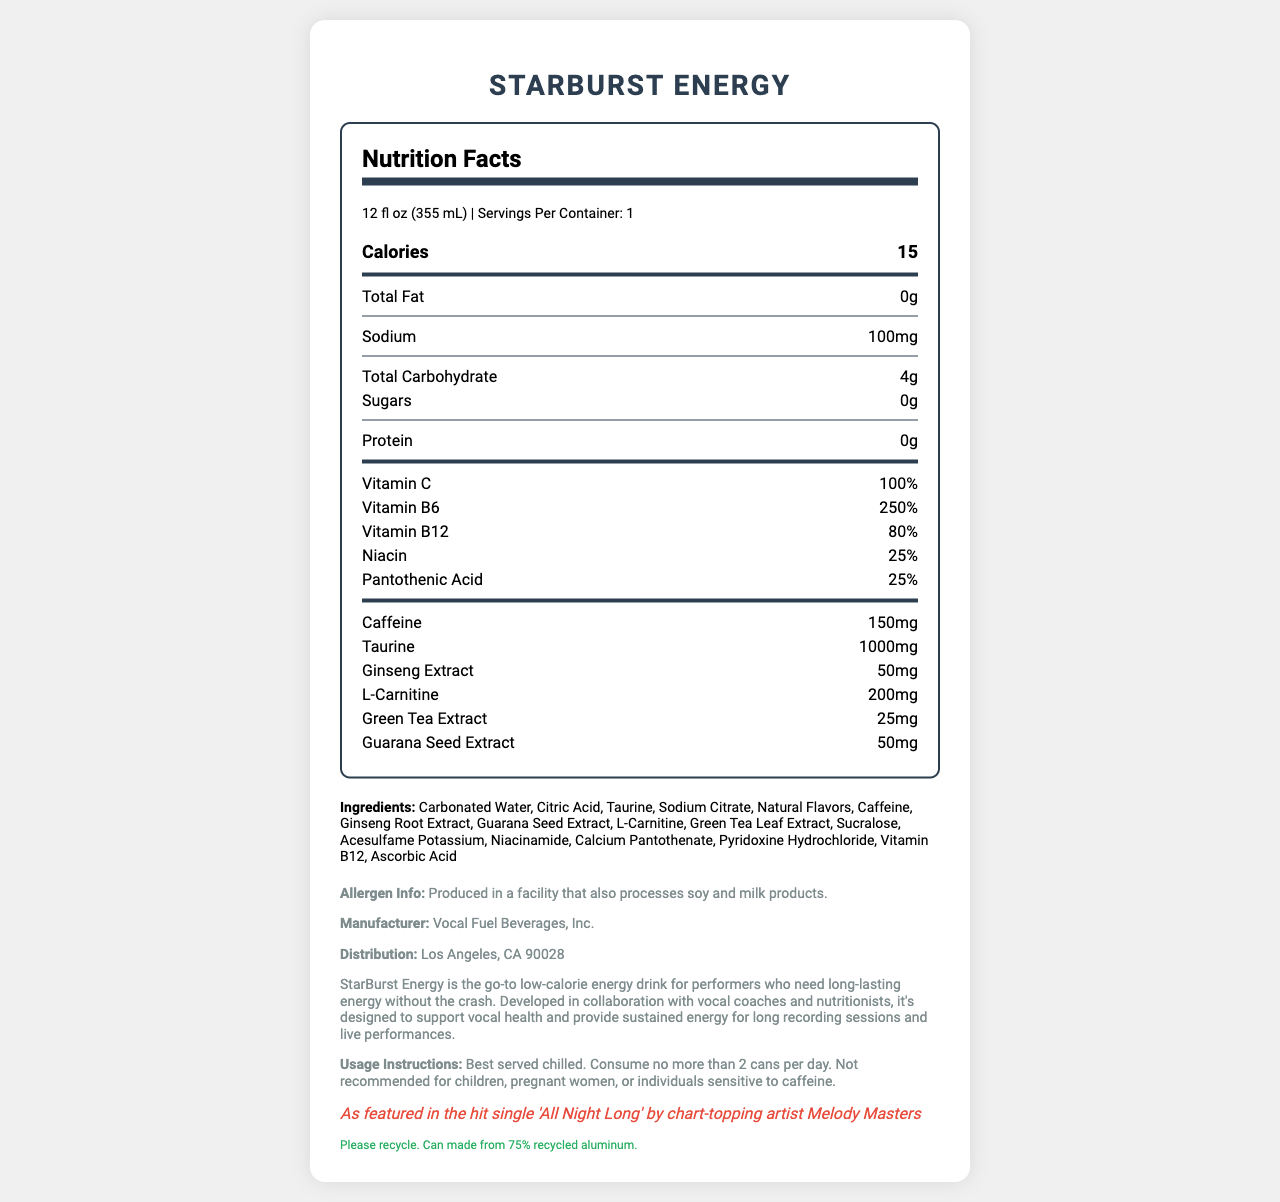what is the serving size of StarBurst Energy? The serving size is clearly stated at the beginning of the document under the heading "Nutrition Facts".
Answer: 12 fl oz (355 mL) how many calories are in one serving of StarBurst Energy? The calories count is prominently displayed under the "Nutrition Facts" heading.
Answer: 15 how much caffeine is in one serving of StarBurst Energy? The amount of caffeine is listed under the nutrition details in the document.
Answer: 150 mg what is the percentage of Vitamin B6 in one serving of StarBurst Energy? The percentage of Vitamin B6 is mentioned in the nutrition facts section under vitamins.
Answer: 250% name three ingredients in StarBurst Energy. The ingredients list includes these as part of the overall composition of the drink.
Answer: Carbonated Water, Citric Acid, Taurine which nutritional component is not included in StarBurst Energy? A. Protein B. Sodium C. Sugars D. Total Fat While StarBurst Energy does contain sodium, sugars and total fat, it has 0g of protein, as indicated in the nutrition facts.
Answer: A how many servings are there per container of StarBurst Energy? A. 1 B. 2 C. 3 D. 4 The document indicates that there is one serving per container of StarBurst Energy.
Answer: A does StarBurst Energy contain any allergens? The allergen information states that it is produced in a facility that also processes soy and milk products.
Answer: Yes is StarBurst Energy recommended for children? The usage instructions clearly state that it is not recommended for children.
Answer: No summarize the main features of StarBurst Energy. The document outlines the nutritional facts, ingredients, and unique selling points of StarBurst Energy, making it clear it is tailored for performers needing long-lasting energy.
Answer: StarBurst Energy is a low-calorie energy drink designed for performers, offering 15 calories per 12 fl oz serving, with added vitamins and energy-boosting ingredients like caffeine, taurine, and ginseng extract. It supports vocal health and provides sustained energy, with a recommendation to consume no more than 2 cans per day. who is the manufacturer of StarBurst Energy? The manufacturer's information is listed at the bottom of the document.
Answer: Vocal Fuel Beverages, Inc. where is StarBurst Energy distributed from? The distribution information is provided in the product info section.
Answer: Los Angeles, CA 90028 how much niacin does one serving of StarBurst Energy contain? The percentage of niacin is stated in the nutrition facts section under vitamins.
Answer: 25% how much taurine is in StarBurst Energy? The amount of taurine is specified in the nutrition facts section under chemistry components.
Answer: 1000 mg which artist endorses StarBurst Energy? The celebrity endorsement by Melody Masters is mentioned in the product information section.
Answer: Melody Masters can you determine the price of StarBurst Energy from the document? The document does not provide any information regarding the price of the product.
Answer: Cannot be determined 